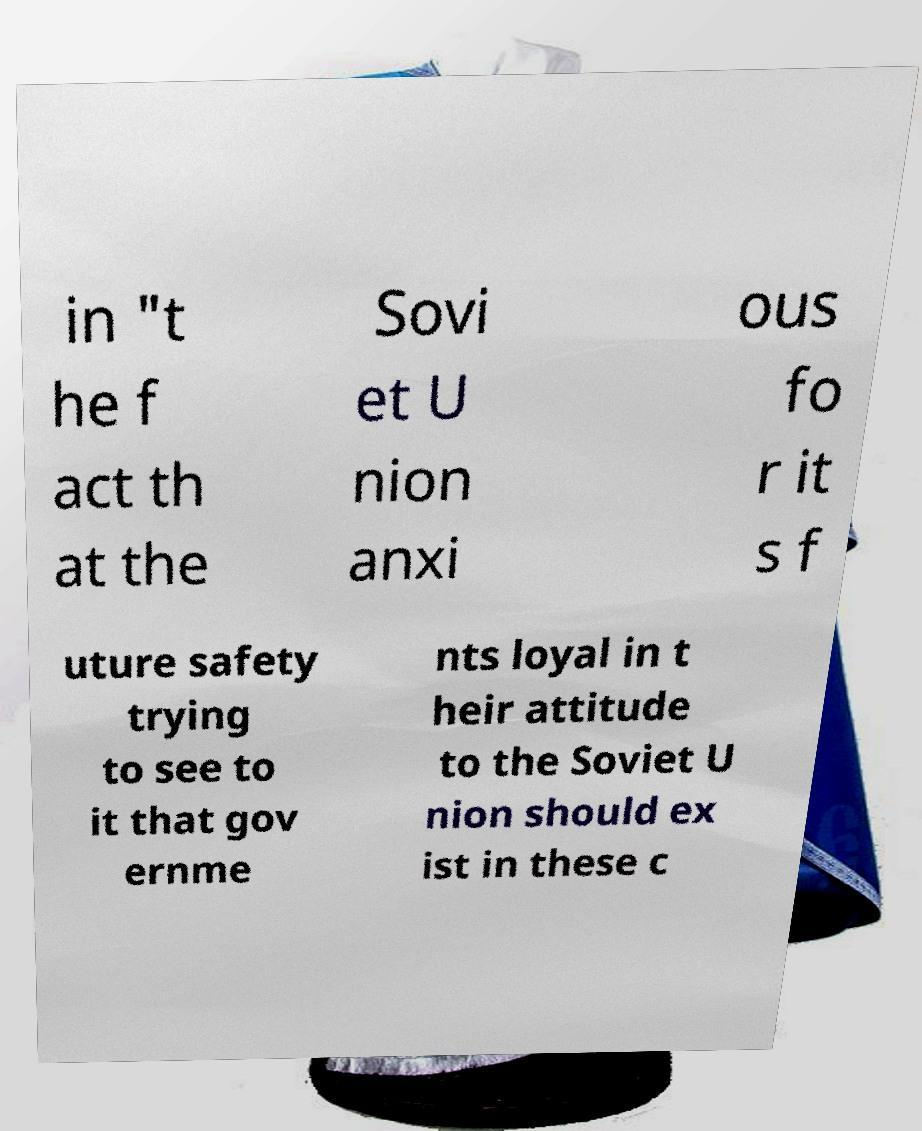Could you assist in decoding the text presented in this image and type it out clearly? in "t he f act th at the Sovi et U nion anxi ous fo r it s f uture safety trying to see to it that gov ernme nts loyal in t heir attitude to the Soviet U nion should ex ist in these c 